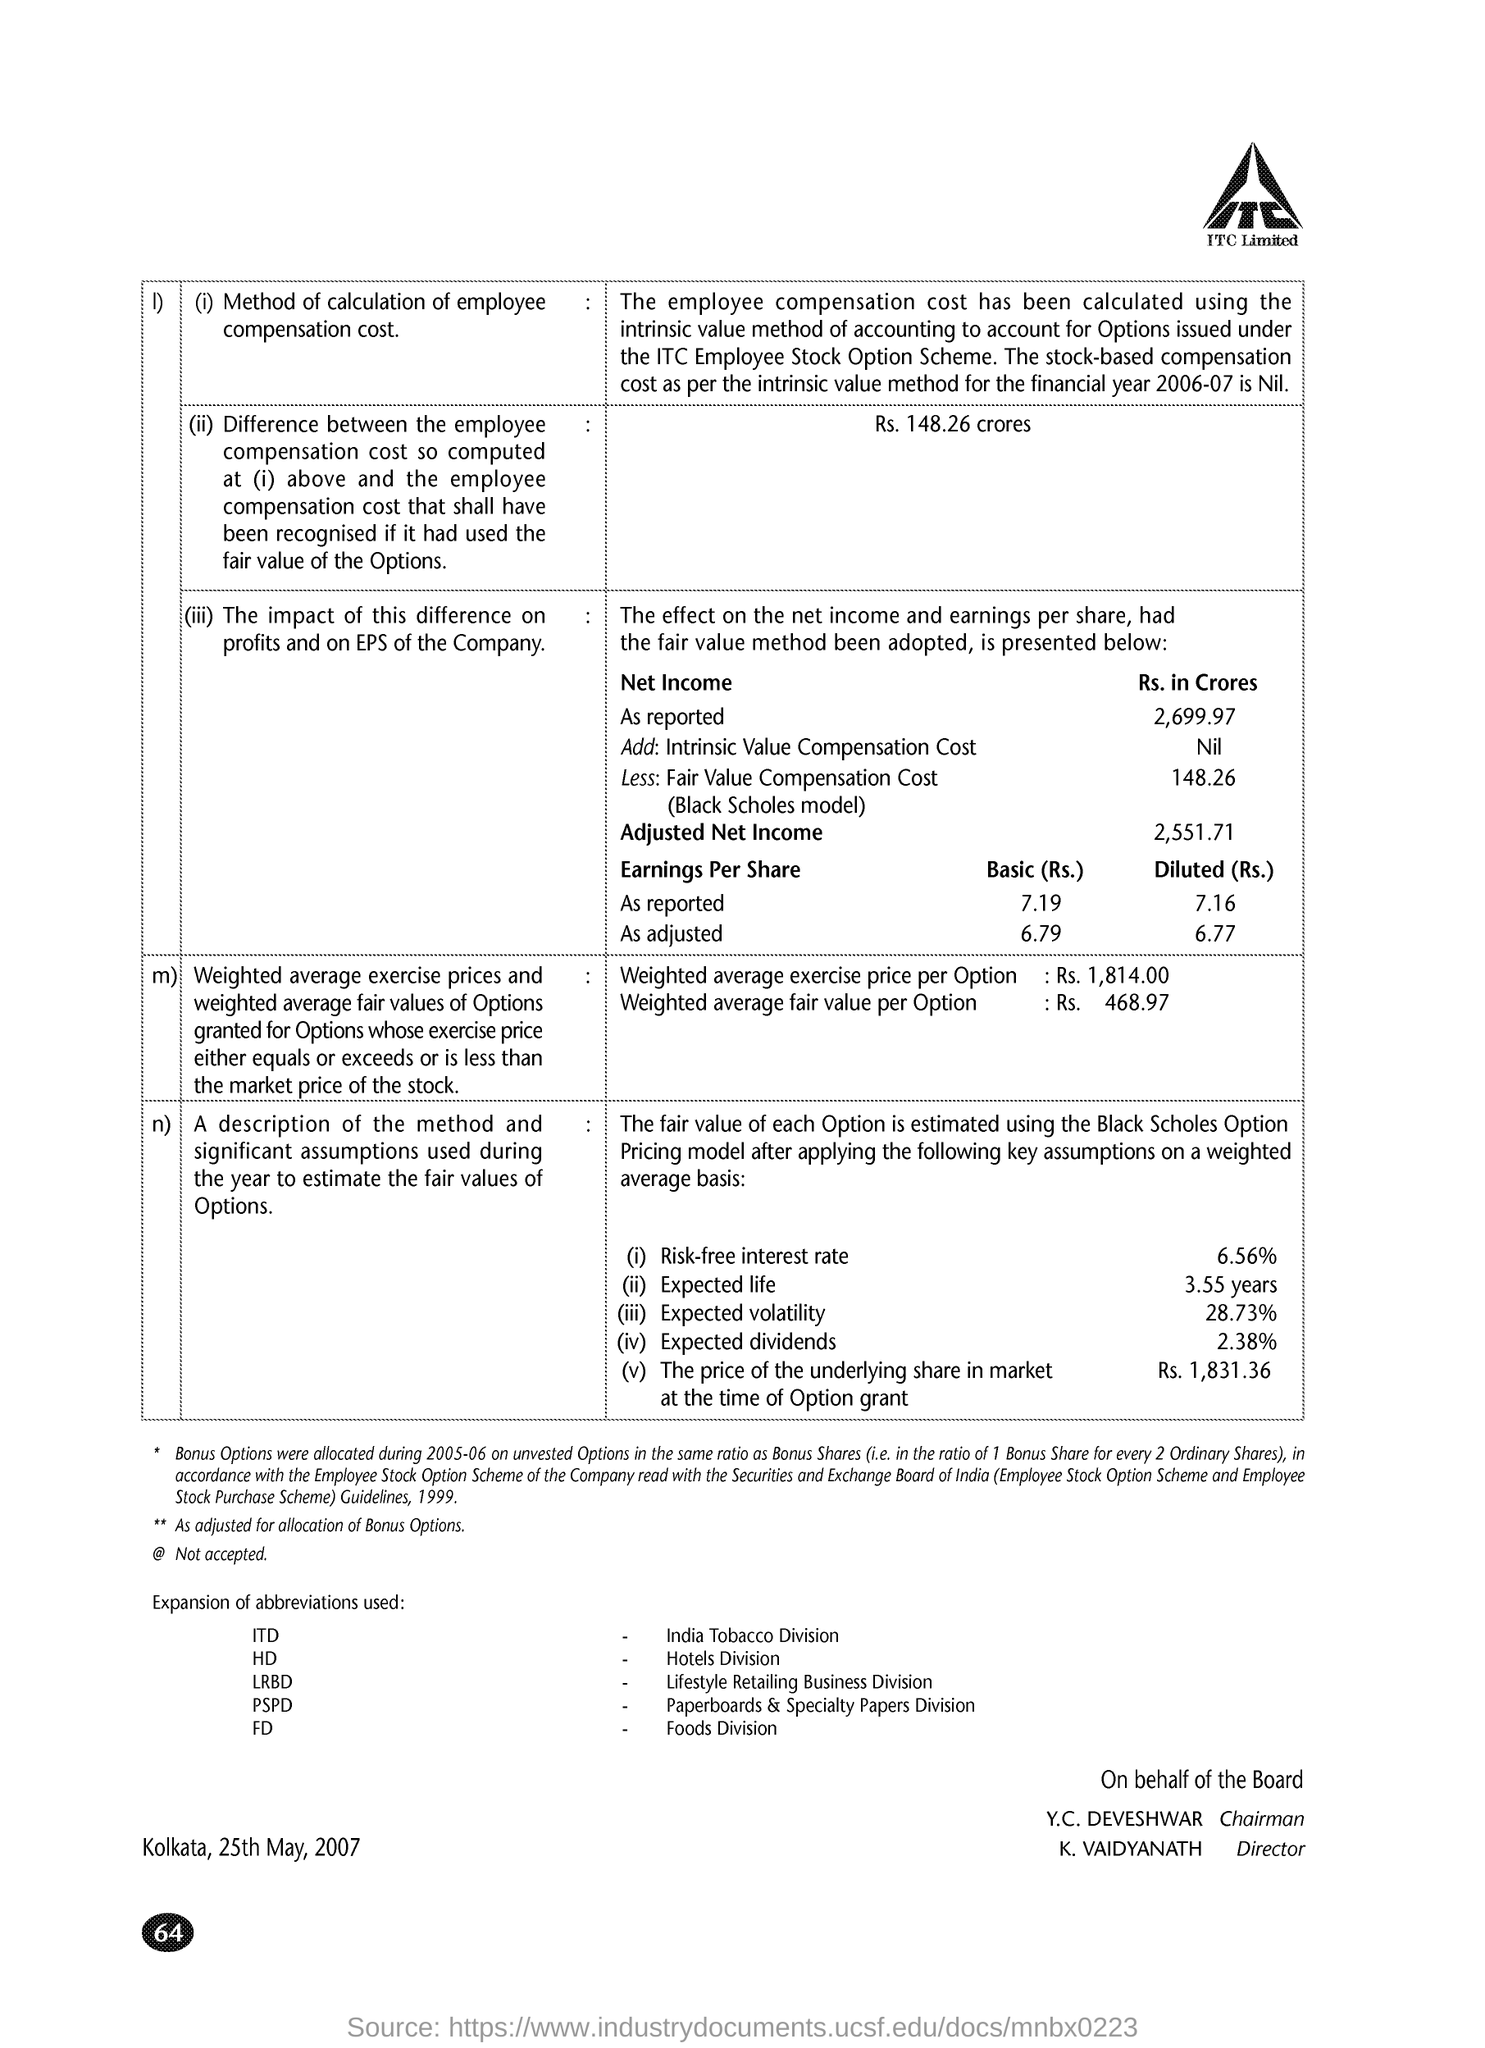What is the weighted average exercise price per Option?
Your answer should be very brief. Rs. 1814.00. What is the weighted average fair value per Option?
Provide a short and direct response. Rs. 468.97. What is the price of the underlying share in market at the time of Option grant?
Provide a succinct answer. Rs. 1,831.36. What is the fullform of ITD?
Ensure brevity in your answer.  India Tobacco Division. What is the fullform of LRBD?
Offer a terse response. Lifestyle Retailing Business Division. What is the page no mentioned in this document?
Provide a succinct answer. 64. 